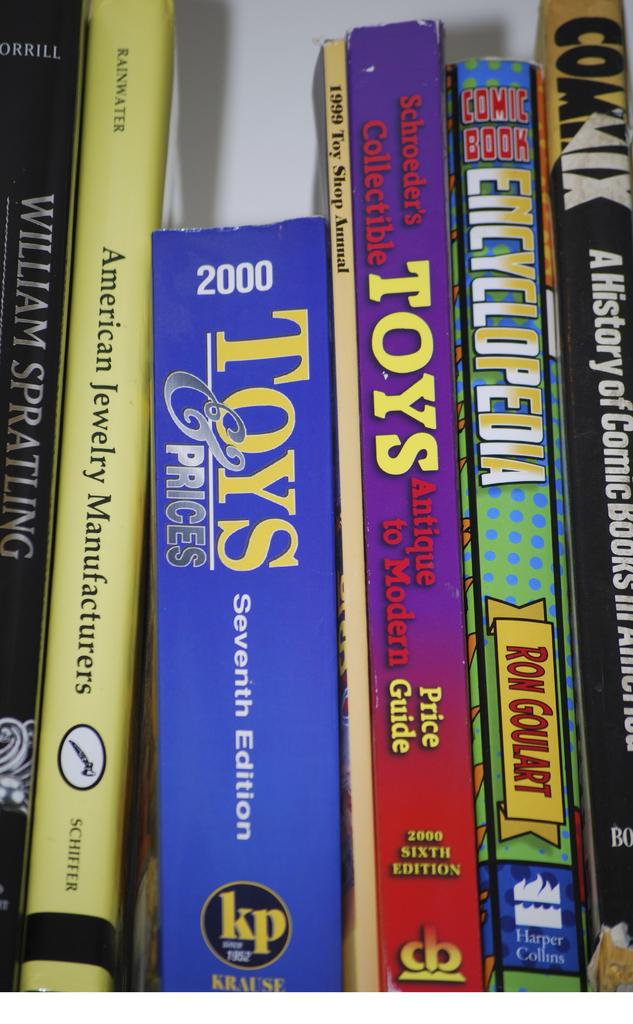Provide a one-sentence caption for the provided image. Books about toys, jewelry, encyclopedia, and history lined up together. 